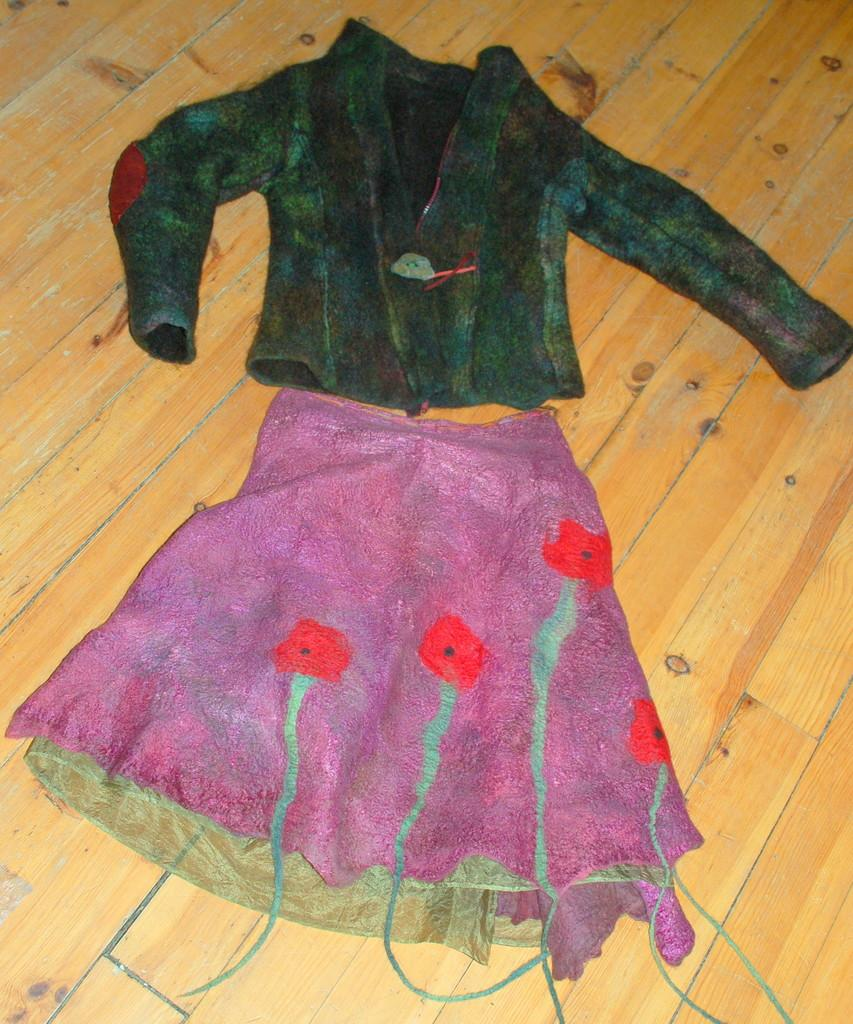What type of clothing is in the image? There is a dress in the image. What is the dress placed on? The dress is on a brown surface. What colors can be seen on the dress? The dress has green and pink colors. How many wings can be seen on the dress in the image? There are no wings present on the dress in the image. What type of lizards can be seen crawling on the dress in the image? There are no lizards present on the dress in the image. 